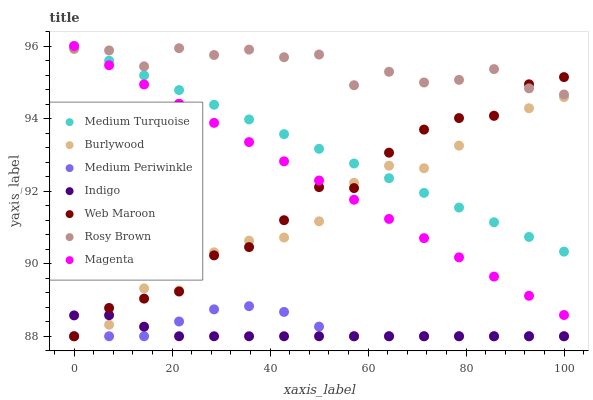Does Indigo have the minimum area under the curve?
Answer yes or no. Yes. Does Rosy Brown have the maximum area under the curve?
Answer yes or no. Yes. Does Burlywood have the minimum area under the curve?
Answer yes or no. No. Does Burlywood have the maximum area under the curve?
Answer yes or no. No. Is Magenta the smoothest?
Answer yes or no. Yes. Is Rosy Brown the roughest?
Answer yes or no. Yes. Is Burlywood the smoothest?
Answer yes or no. No. Is Burlywood the roughest?
Answer yes or no. No. Does Indigo have the lowest value?
Answer yes or no. Yes. Does Rosy Brown have the lowest value?
Answer yes or no. No. Does Magenta have the highest value?
Answer yes or no. Yes. Does Burlywood have the highest value?
Answer yes or no. No. Is Medium Periwinkle less than Magenta?
Answer yes or no. Yes. Is Rosy Brown greater than Burlywood?
Answer yes or no. Yes. Does Web Maroon intersect Indigo?
Answer yes or no. Yes. Is Web Maroon less than Indigo?
Answer yes or no. No. Is Web Maroon greater than Indigo?
Answer yes or no. No. Does Medium Periwinkle intersect Magenta?
Answer yes or no. No. 